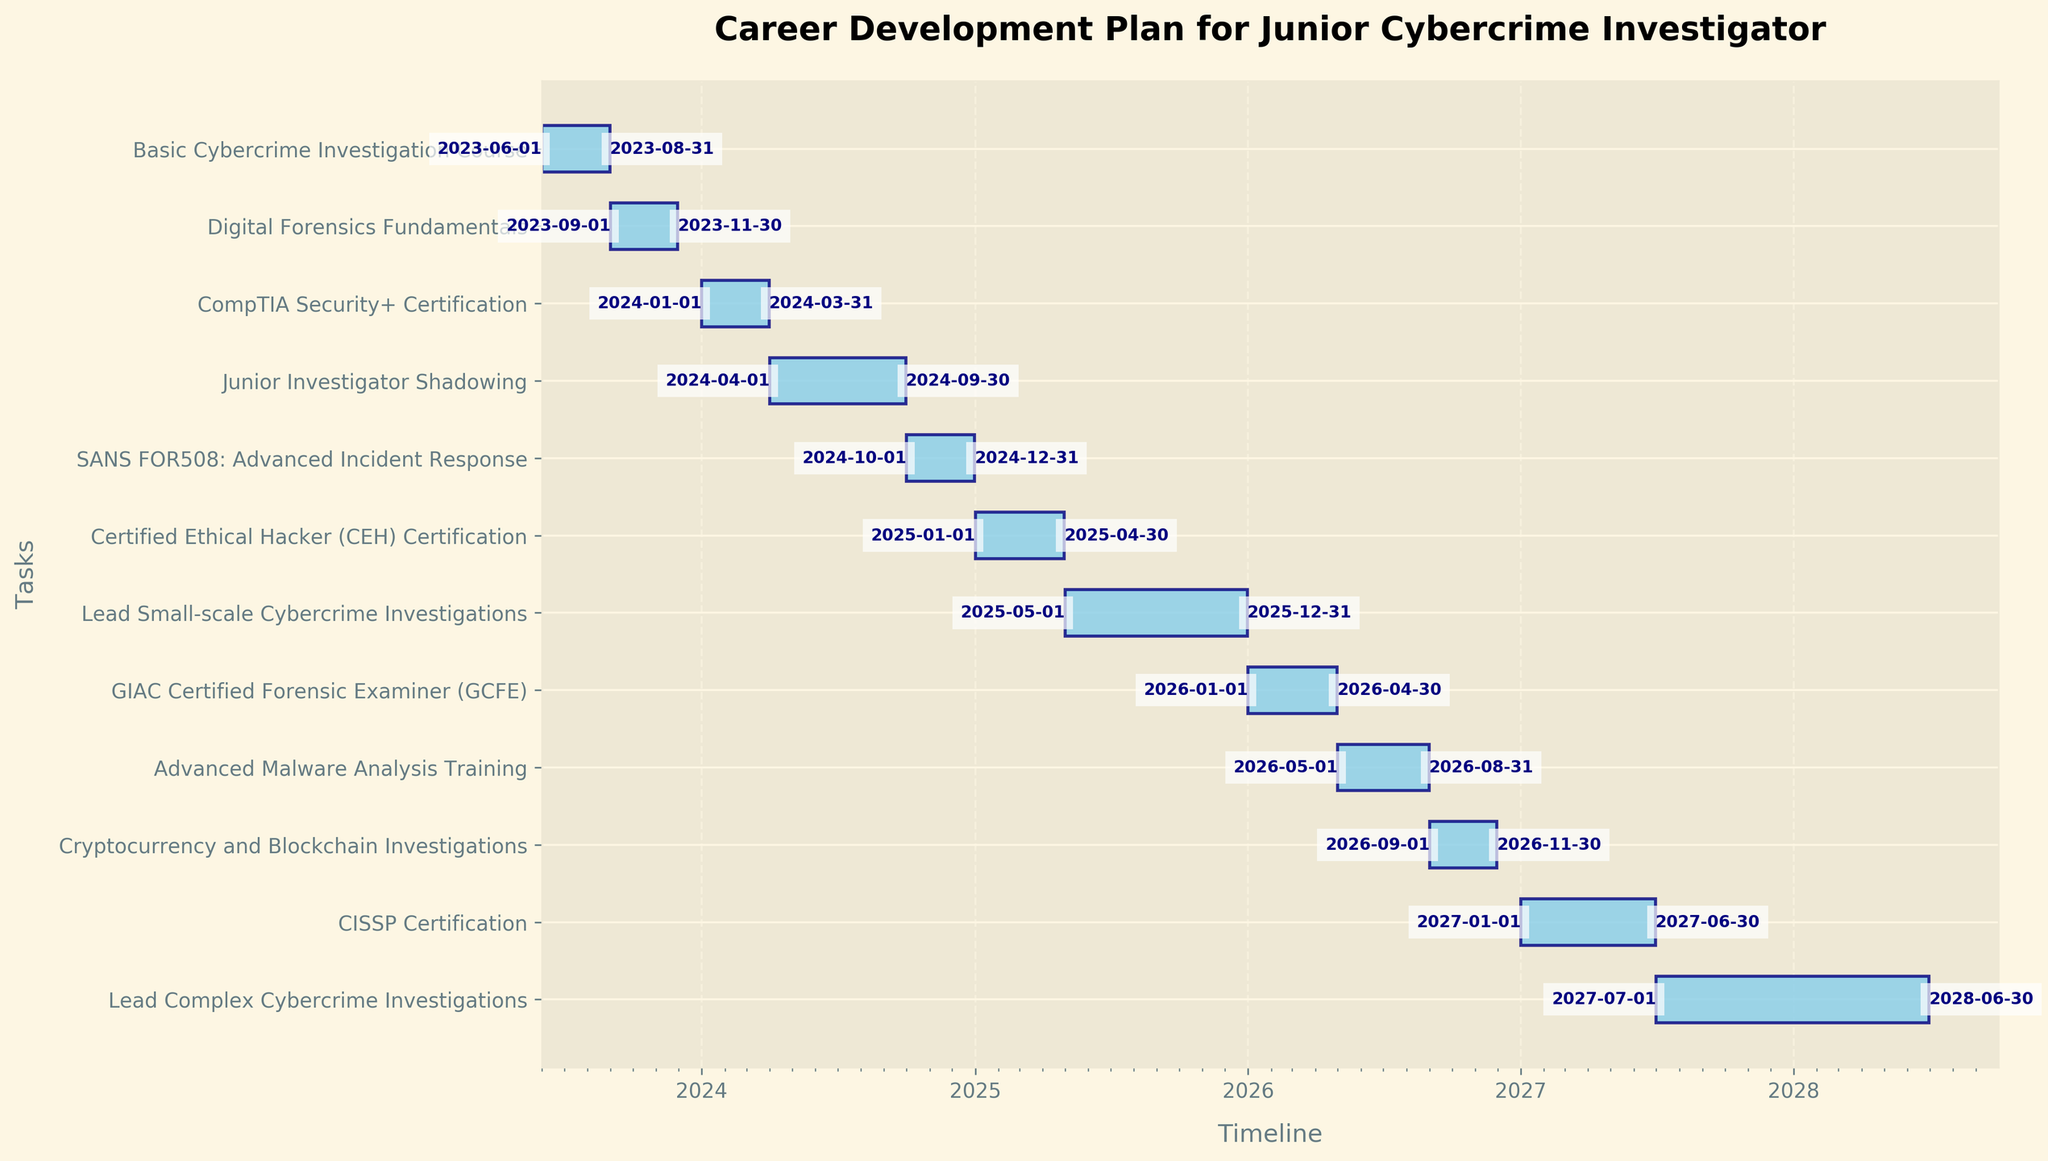What is the title of the chart? The title is typically displayed at the top of the chart, easily visible. In this case, it reads: "Career Development Plan for Junior Cybercrime Investigator".
Answer: Career Development Plan for Junior Cybercrime Investigator How many tasks are listed in the career development plan? To find the number of tasks, count the number of individual bars or y-tick labels. In the chart, there are 12 tasks listed.
Answer: 12 Which task has the longest duration? By comparing the lengths of the bars, identify the one that spans the most extended period. "Lead Complex Cybercrime Investigations" spans from 2027-07-01 to 2028-06-30, making it the longest.
Answer: Lead Complex Cybercrime Investigations During which year are the most tasks scheduled? Observe the x-axis and notice that 2025 has three tasks overlapping: "Certified Ethical Hacker (CEH) Certification," "Lead Small-scale Cybercrime Investigations," and "GIAC Certified Forensic Examiner (GCFE)".
Answer: 2025 What are the start and end dates of the "CISSP Certification"? Look at the "CISSP Certification" bar to see the exact dates marked at its ends. It starts on 2027-01-01 and ends on 2027-06-30.
Answer: 2027-01-01 to 2027-06-30 Which tasks are scheduled to start in 2026? Refer to the start dates along the chart. The tasks starting in 2026 are "GIAC Certified Forensic Examiner (GCFE)" starting on 2026-01-01, "Advanced Malware Analysis Training" on 2026-05-01, and "Cryptocurrency and Blockchain Investigations" on 2026-09-01.
Answer: GIAC Certified Forensic Examiner (GCFE), Advanced Malware Analysis Training, Cryptocurrency and Blockchain Investigations Which task directly follows the "Basic Cybercrime Investigation Course"? Identify the end date of the "Basic Cybercrime Investigation Course" and see which task starts right after it. The "Digital Forensics Fundamentals" starts on 2023-09-01, directly following the prior task.
Answer: Digital Forensics Fundamentals How long does the "Junior Investigator Shadowing" last? Look at the duration of the bar labeled "Junior Investigator Shadowing," spanning from 2024-04-01 to 2024-09-30. The duration is six months.
Answer: 6 months When does the "Lead Small-scale Cybercrime Investigations" task end? Check the end date at the far right end of the "Lead Small-scale Cybercrime Investigations" bar, which is 2025-12-31.
Answer: 2025-12-31 What task starts in 2024 and ends in 2024? Look for tasks where both the start and end dates fall within 2024. The "Junior Investigator Shadowing" starts on 2024-04-01 and ends on 2024-09-30, along with the "SANS FOR508: Advanced Incident Response" from 2024-10-01 to 2024-12-31.
Answer: Junior Investigator Shadowing, SANS FOR508: Advanced Incident Response 